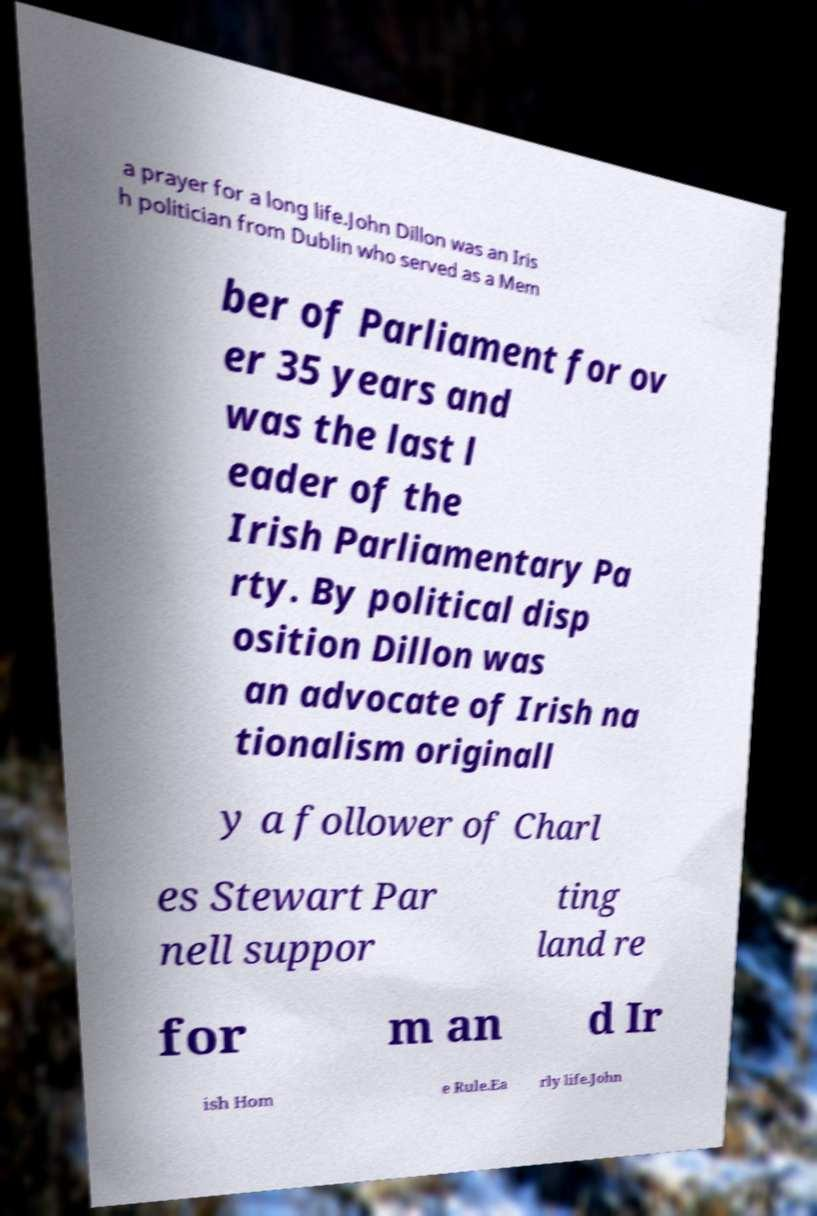Can you read and provide the text displayed in the image?This photo seems to have some interesting text. Can you extract and type it out for me? a prayer for a long life.John Dillon was an Iris h politician from Dublin who served as a Mem ber of Parliament for ov er 35 years and was the last l eader of the Irish Parliamentary Pa rty. By political disp osition Dillon was an advocate of Irish na tionalism originall y a follower of Charl es Stewart Par nell suppor ting land re for m an d Ir ish Hom e Rule.Ea rly life.John 